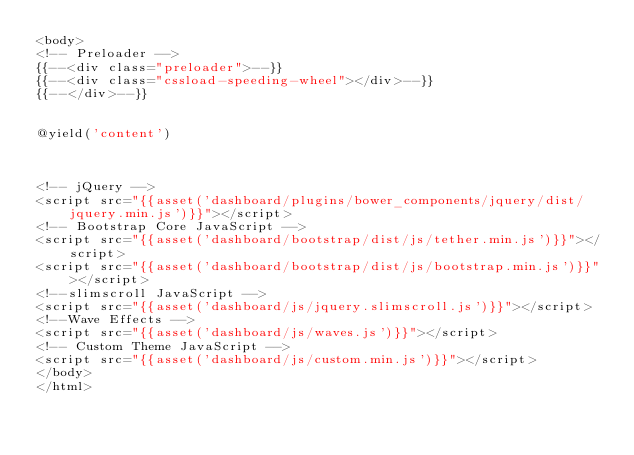<code> <loc_0><loc_0><loc_500><loc_500><_PHP_><body>
<!-- Preloader -->
{{--<div class="preloader">--}}
{{--<div class="cssload-speeding-wheel"></div>--}}
{{--</div>--}}


@yield('content')



<!-- jQuery -->
<script src="{{asset('dashboard/plugins/bower_components/jquery/dist/jquery.min.js')}}"></script>
<!-- Bootstrap Core JavaScript -->
<script src="{{asset('dashboard/bootstrap/dist/js/tether.min.js')}}"></script>
<script src="{{asset('dashboard/bootstrap/dist/js/bootstrap.min.js')}}"></script>
<!--slimscroll JavaScript -->
<script src="{{asset('dashboard/js/jquery.slimscroll.js')}}"></script>
<!--Wave Effects -->
<script src="{{asset('dashboard/js/waves.js')}}"></script>
<!-- Custom Theme JavaScript -->
<script src="{{asset('dashboard/js/custom.min.js')}}"></script>
</body>
</html>

</code> 